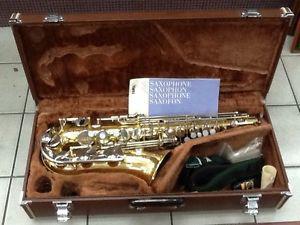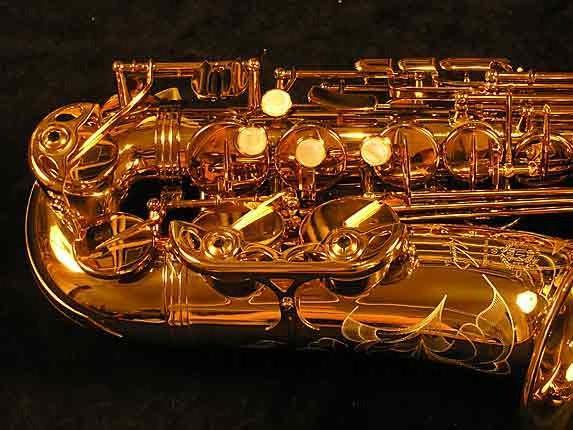The first image is the image on the left, the second image is the image on the right. Analyze the images presented: Is the assertion "At least one of the saxophones is polished." valid? Answer yes or no. Yes. The first image is the image on the left, the second image is the image on the right. Analyze the images presented: Is the assertion "In at least one image, the close up picture reveals text that has been engraved into the saxophone." valid? Answer yes or no. No. 